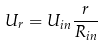<formula> <loc_0><loc_0><loc_500><loc_500>U _ { r } = U _ { i n } \frac { r } { R _ { i n } }</formula> 